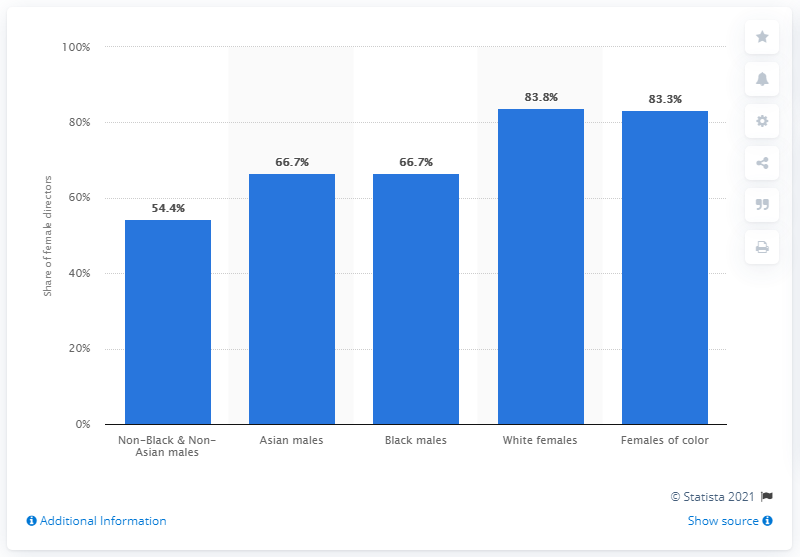Give some essential details in this illustration. Approximately 84% of females of color had only one film released between 2007 and 2017. 